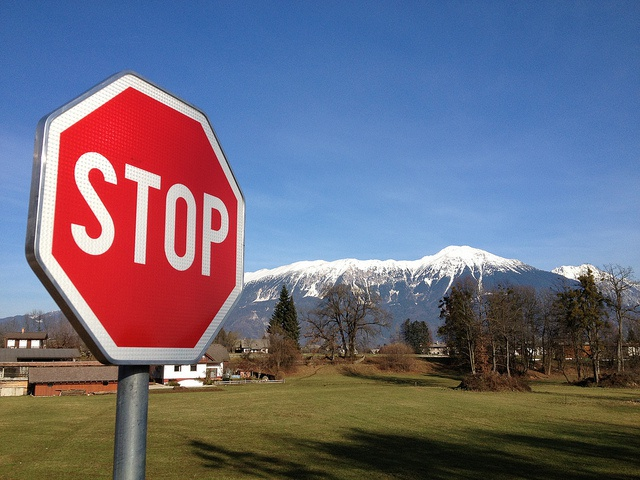Describe the objects in this image and their specific colors. I can see a stop sign in blue, brown, lightgray, and darkgray tones in this image. 